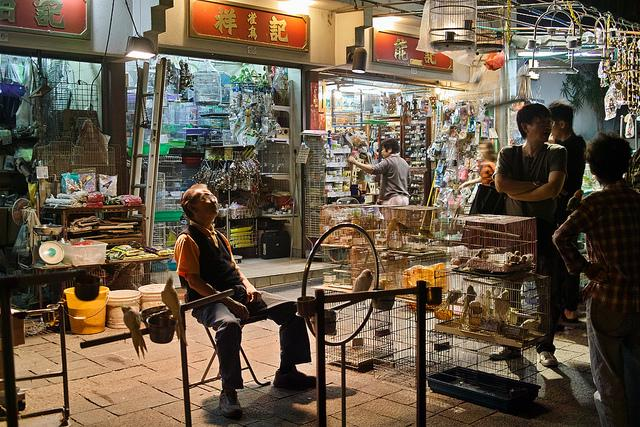The birds seen out of their cage here are sold for what purpose?

Choices:
A) dinner
B) hat feathers
C) stealing jewels
D) pets pets 